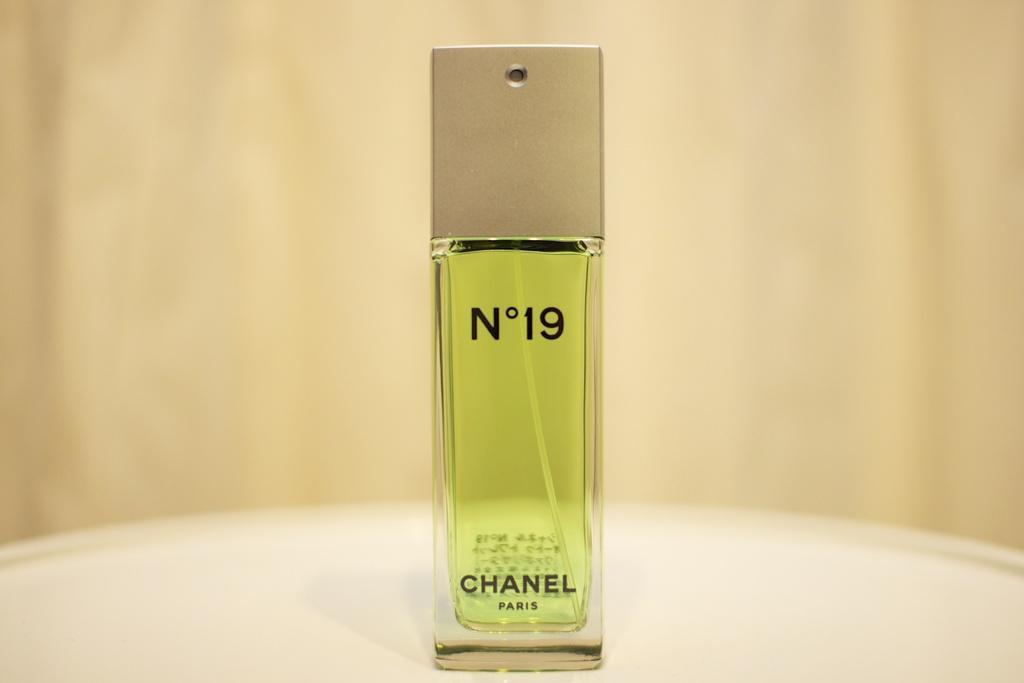Could you give a brief overview of what you see in this image? This picture consists of a perfume bottle placed on a table 